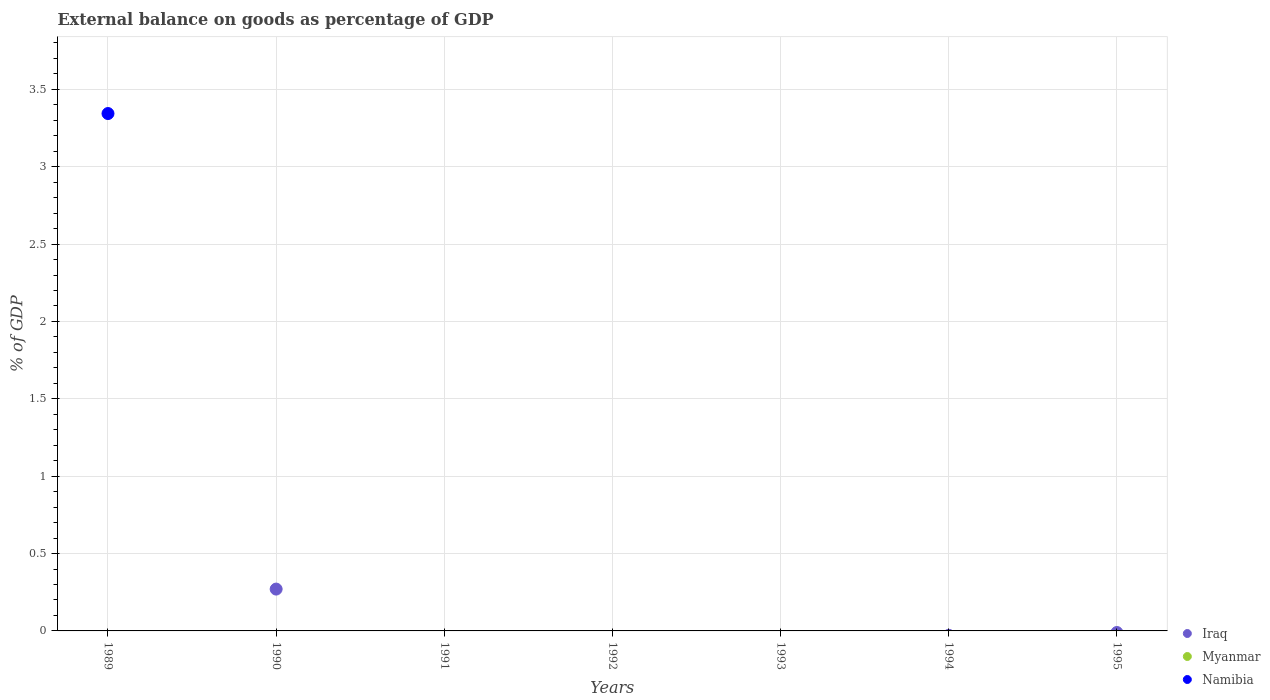How many different coloured dotlines are there?
Provide a short and direct response. 2. Is the number of dotlines equal to the number of legend labels?
Offer a terse response. No. Across all years, what is the maximum external balance on goods as percentage of GDP in Iraq?
Give a very brief answer. 0.27. Across all years, what is the minimum external balance on goods as percentage of GDP in Iraq?
Give a very brief answer. 0. What is the total external balance on goods as percentage of GDP in Iraq in the graph?
Offer a very short reply. 0.27. What is the difference between the external balance on goods as percentage of GDP in Iraq in 1995 and the external balance on goods as percentage of GDP in Myanmar in 1990?
Offer a terse response. 0. In how many years, is the external balance on goods as percentage of GDP in Iraq greater than 2.7 %?
Make the answer very short. 0. What is the difference between the highest and the lowest external balance on goods as percentage of GDP in Namibia?
Your answer should be very brief. 3.34. Does the external balance on goods as percentage of GDP in Namibia monotonically increase over the years?
Offer a terse response. No. How many years are there in the graph?
Make the answer very short. 7. Are the values on the major ticks of Y-axis written in scientific E-notation?
Ensure brevity in your answer.  No. Where does the legend appear in the graph?
Provide a succinct answer. Bottom right. How many legend labels are there?
Your answer should be very brief. 3. How are the legend labels stacked?
Your answer should be very brief. Vertical. What is the title of the graph?
Give a very brief answer. External balance on goods as percentage of GDP. What is the label or title of the X-axis?
Your response must be concise. Years. What is the label or title of the Y-axis?
Your answer should be very brief. % of GDP. What is the % of GDP in Iraq in 1989?
Make the answer very short. 0. What is the % of GDP in Namibia in 1989?
Make the answer very short. 3.34. What is the % of GDP of Iraq in 1990?
Your response must be concise. 0.27. What is the % of GDP of Namibia in 1990?
Make the answer very short. 0. What is the % of GDP in Myanmar in 1992?
Provide a short and direct response. 0. What is the % of GDP of Namibia in 1992?
Keep it short and to the point. 0. What is the % of GDP in Iraq in 1993?
Provide a succinct answer. 0. What is the % of GDP of Namibia in 1993?
Provide a short and direct response. 0. What is the % of GDP of Iraq in 1994?
Ensure brevity in your answer.  0. What is the % of GDP of Iraq in 1995?
Provide a short and direct response. 0. What is the % of GDP of Namibia in 1995?
Your answer should be very brief. 0. Across all years, what is the maximum % of GDP of Iraq?
Make the answer very short. 0.27. Across all years, what is the maximum % of GDP of Namibia?
Offer a terse response. 3.34. Across all years, what is the minimum % of GDP of Iraq?
Your response must be concise. 0. Across all years, what is the minimum % of GDP in Namibia?
Give a very brief answer. 0. What is the total % of GDP in Iraq in the graph?
Offer a very short reply. 0.27. What is the total % of GDP in Myanmar in the graph?
Your answer should be very brief. 0. What is the total % of GDP of Namibia in the graph?
Provide a short and direct response. 3.34. What is the average % of GDP in Iraq per year?
Offer a terse response. 0.04. What is the average % of GDP in Namibia per year?
Give a very brief answer. 0.48. What is the difference between the highest and the lowest % of GDP of Iraq?
Keep it short and to the point. 0.27. What is the difference between the highest and the lowest % of GDP in Namibia?
Your answer should be compact. 3.34. 